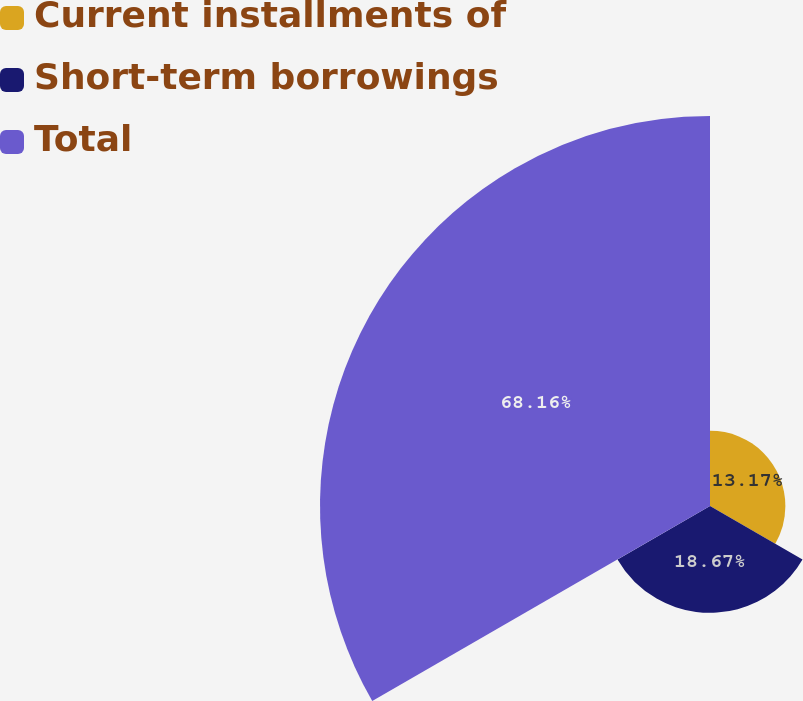<chart> <loc_0><loc_0><loc_500><loc_500><pie_chart><fcel>Current installments of<fcel>Short-term borrowings<fcel>Total<nl><fcel>13.17%<fcel>18.67%<fcel>68.16%<nl></chart> 